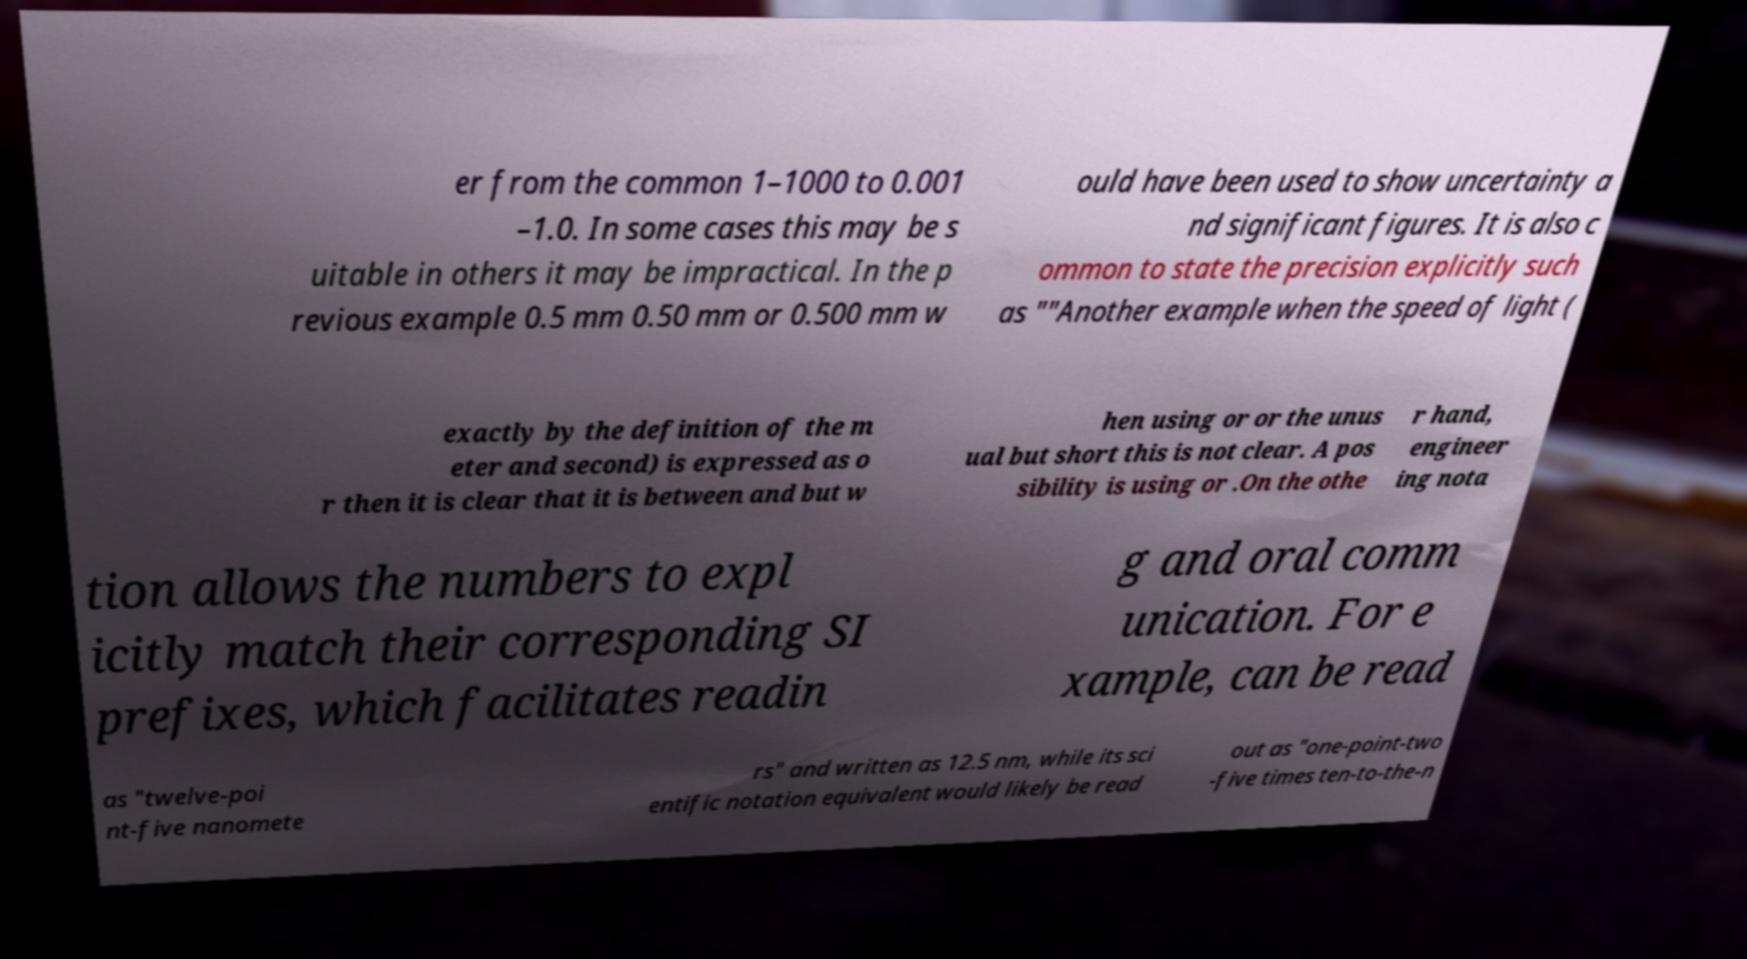What messages or text are displayed in this image? I need them in a readable, typed format. er from the common 1–1000 to 0.001 –1.0. In some cases this may be s uitable in others it may be impractical. In the p revious example 0.5 mm 0.50 mm or 0.500 mm w ould have been used to show uncertainty a nd significant figures. It is also c ommon to state the precision explicitly such as ""Another example when the speed of light ( exactly by the definition of the m eter and second) is expressed as o r then it is clear that it is between and but w hen using or or the unus ual but short this is not clear. A pos sibility is using or .On the othe r hand, engineer ing nota tion allows the numbers to expl icitly match their corresponding SI prefixes, which facilitates readin g and oral comm unication. For e xample, can be read as "twelve-poi nt-five nanomete rs" and written as 12.5 nm, while its sci entific notation equivalent would likely be read out as "one-point-two -five times ten-to-the-n 